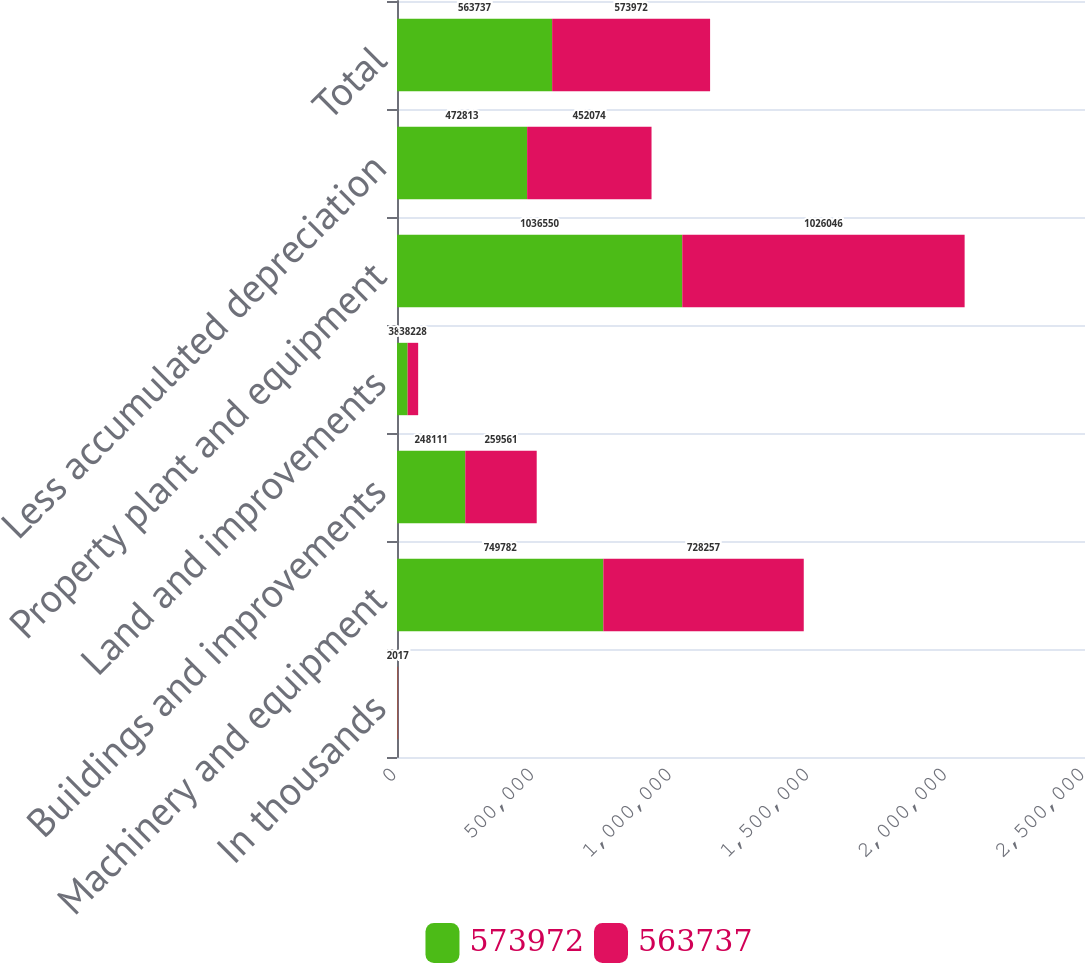Convert chart. <chart><loc_0><loc_0><loc_500><loc_500><stacked_bar_chart><ecel><fcel>In thousands<fcel>Machinery and equipment<fcel>Buildings and improvements<fcel>Land and improvements<fcel>Property plant and equipment<fcel>Less accumulated depreciation<fcel>Total<nl><fcel>573972<fcel>2018<fcel>749782<fcel>248111<fcel>38657<fcel>1.03655e+06<fcel>472813<fcel>563737<nl><fcel>563737<fcel>2017<fcel>728257<fcel>259561<fcel>38228<fcel>1.02605e+06<fcel>452074<fcel>573972<nl></chart> 